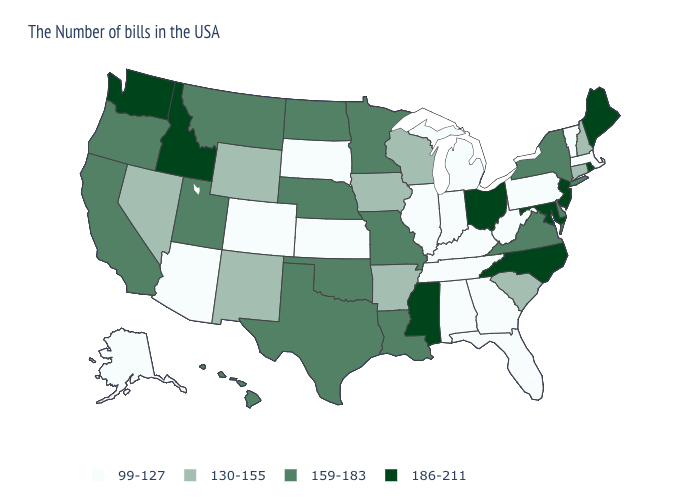What is the value of Oregon?
Give a very brief answer. 159-183. What is the highest value in the MidWest ?
Write a very short answer. 186-211. Among the states that border New York , does New Jersey have the highest value?
Be succinct. Yes. Name the states that have a value in the range 99-127?
Quick response, please. Massachusetts, Vermont, Pennsylvania, West Virginia, Florida, Georgia, Michigan, Kentucky, Indiana, Alabama, Tennessee, Illinois, Kansas, South Dakota, Colorado, Arizona, Alaska. What is the value of Illinois?
Concise answer only. 99-127. Name the states that have a value in the range 159-183?
Keep it brief. New York, Delaware, Virginia, Louisiana, Missouri, Minnesota, Nebraska, Oklahoma, Texas, North Dakota, Utah, Montana, California, Oregon, Hawaii. Name the states that have a value in the range 130-155?
Answer briefly. New Hampshire, Connecticut, South Carolina, Wisconsin, Arkansas, Iowa, Wyoming, New Mexico, Nevada. Name the states that have a value in the range 159-183?
Short answer required. New York, Delaware, Virginia, Louisiana, Missouri, Minnesota, Nebraska, Oklahoma, Texas, North Dakota, Utah, Montana, California, Oregon, Hawaii. Among the states that border Rhode Island , does Massachusetts have the lowest value?
Keep it brief. Yes. Which states have the highest value in the USA?
Short answer required. Maine, Rhode Island, New Jersey, Maryland, North Carolina, Ohio, Mississippi, Idaho, Washington. What is the value of Tennessee?
Quick response, please. 99-127. Name the states that have a value in the range 186-211?
Write a very short answer. Maine, Rhode Island, New Jersey, Maryland, North Carolina, Ohio, Mississippi, Idaho, Washington. Does Arkansas have the highest value in the USA?
Answer briefly. No. Which states have the lowest value in the South?
Be succinct. West Virginia, Florida, Georgia, Kentucky, Alabama, Tennessee. Name the states that have a value in the range 99-127?
Quick response, please. Massachusetts, Vermont, Pennsylvania, West Virginia, Florida, Georgia, Michigan, Kentucky, Indiana, Alabama, Tennessee, Illinois, Kansas, South Dakota, Colorado, Arizona, Alaska. 